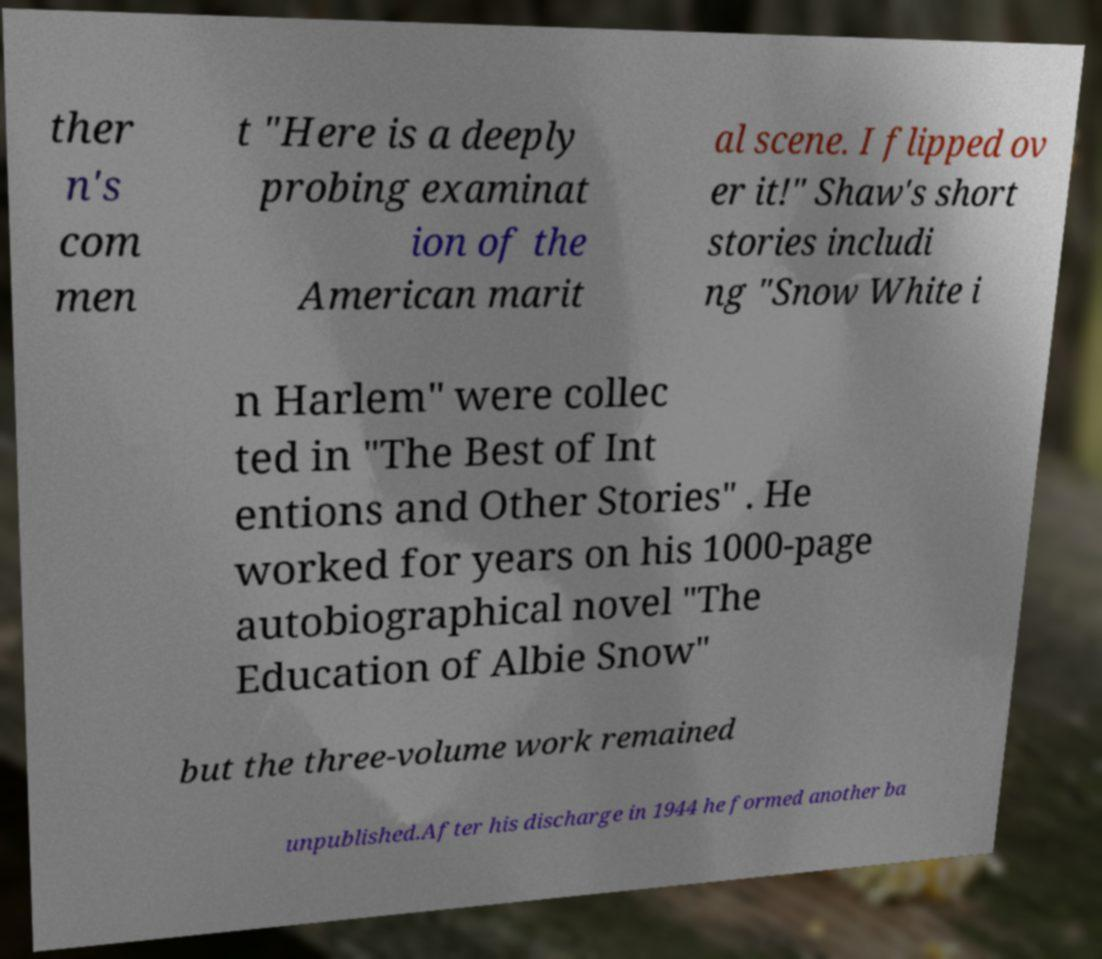For documentation purposes, I need the text within this image transcribed. Could you provide that? ther n's com men t "Here is a deeply probing examinat ion of the American marit al scene. I flipped ov er it!" Shaw's short stories includi ng "Snow White i n Harlem" were collec ted in "The Best of Int entions and Other Stories" . He worked for years on his 1000-page autobiographical novel "The Education of Albie Snow" but the three-volume work remained unpublished.After his discharge in 1944 he formed another ba 